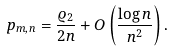Convert formula to latex. <formula><loc_0><loc_0><loc_500><loc_500>p _ { m , n } = \frac { \varrho _ { 2 } } { 2 n } + O \left ( \frac { \log n } { n ^ { 2 } } \right ) .</formula> 